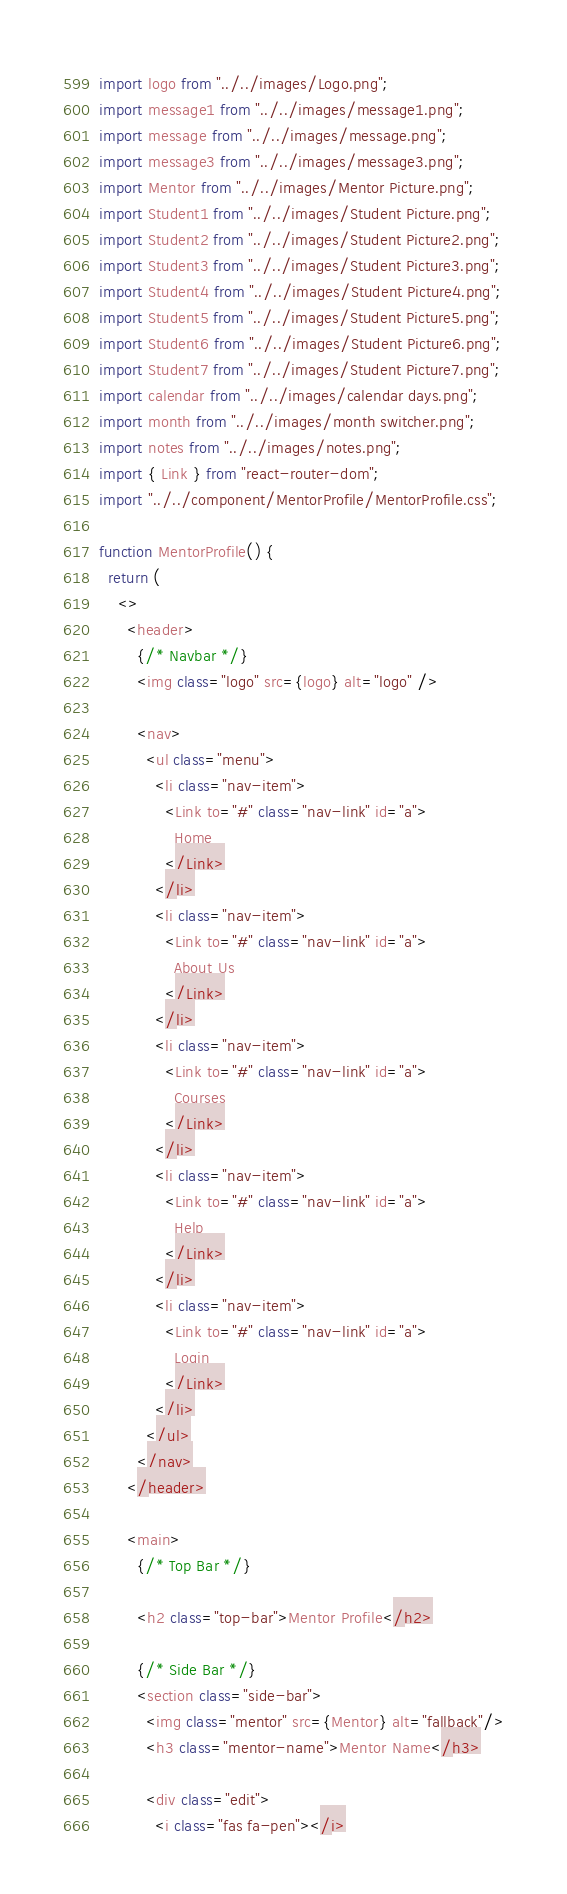Convert code to text. <code><loc_0><loc_0><loc_500><loc_500><_JavaScript_>import logo from "../../images/Logo.png";
import message1 from "../../images/message1.png";
import message from "../../images/message.png";
import message3 from "../../images/message3.png";
import Mentor from "../../images/Mentor Picture.png";
import Student1 from "../../images/Student Picture.png";
import Student2 from "../../images/Student Picture2.png";
import Student3 from "../../images/Student Picture3.png";
import Student4 from "../../images/Student Picture4.png";
import Student5 from "../../images/Student Picture5.png";
import Student6 from "../../images/Student Picture6.png";
import Student7 from "../../images/Student Picture7.png";
import calendar from "../../images/calendar days.png";
import month from "../../images/month switcher.png";
import notes from "../../images/notes.png";
import { Link } from "react-router-dom";
import "../../component/MentorProfile/MentorProfile.css";

function MentorProfile() {
  return (
    <>
      <header>
        {/* Navbar */}
        <img class="logo" src={logo} alt="logo" />

        <nav>
          <ul class="menu">
            <li class="nav-item">
              <Link to="#" class="nav-link" id="a">
                Home
              </Link>
            </li>
            <li class="nav-item">
              <Link to="#" class="nav-link" id="a">
                About Us
              </Link>
            </li>
            <li class="nav-item">
              <Link to="#" class="nav-link" id="a">
                Courses
              </Link>
            </li>
            <li class="nav-item">
              <Link to="#" class="nav-link" id="a">
                Help
              </Link>
            </li>
            <li class="nav-item">
              <Link to="#" class="nav-link" id="a">
                Login
              </Link>
            </li>
          </ul>
        </nav>
      </header>

      <main>
        {/* Top Bar */}

        <h2 class="top-bar">Mentor Profile</h2>

        {/* Side Bar */}
        <section class="side-bar">
          <img class="mentor" src={Mentor} alt="fallback"/>
          <h3 class="mentor-name">Mentor Name</h3>

          <div class="edit">
            <i class="fas fa-pen"></i></code> 